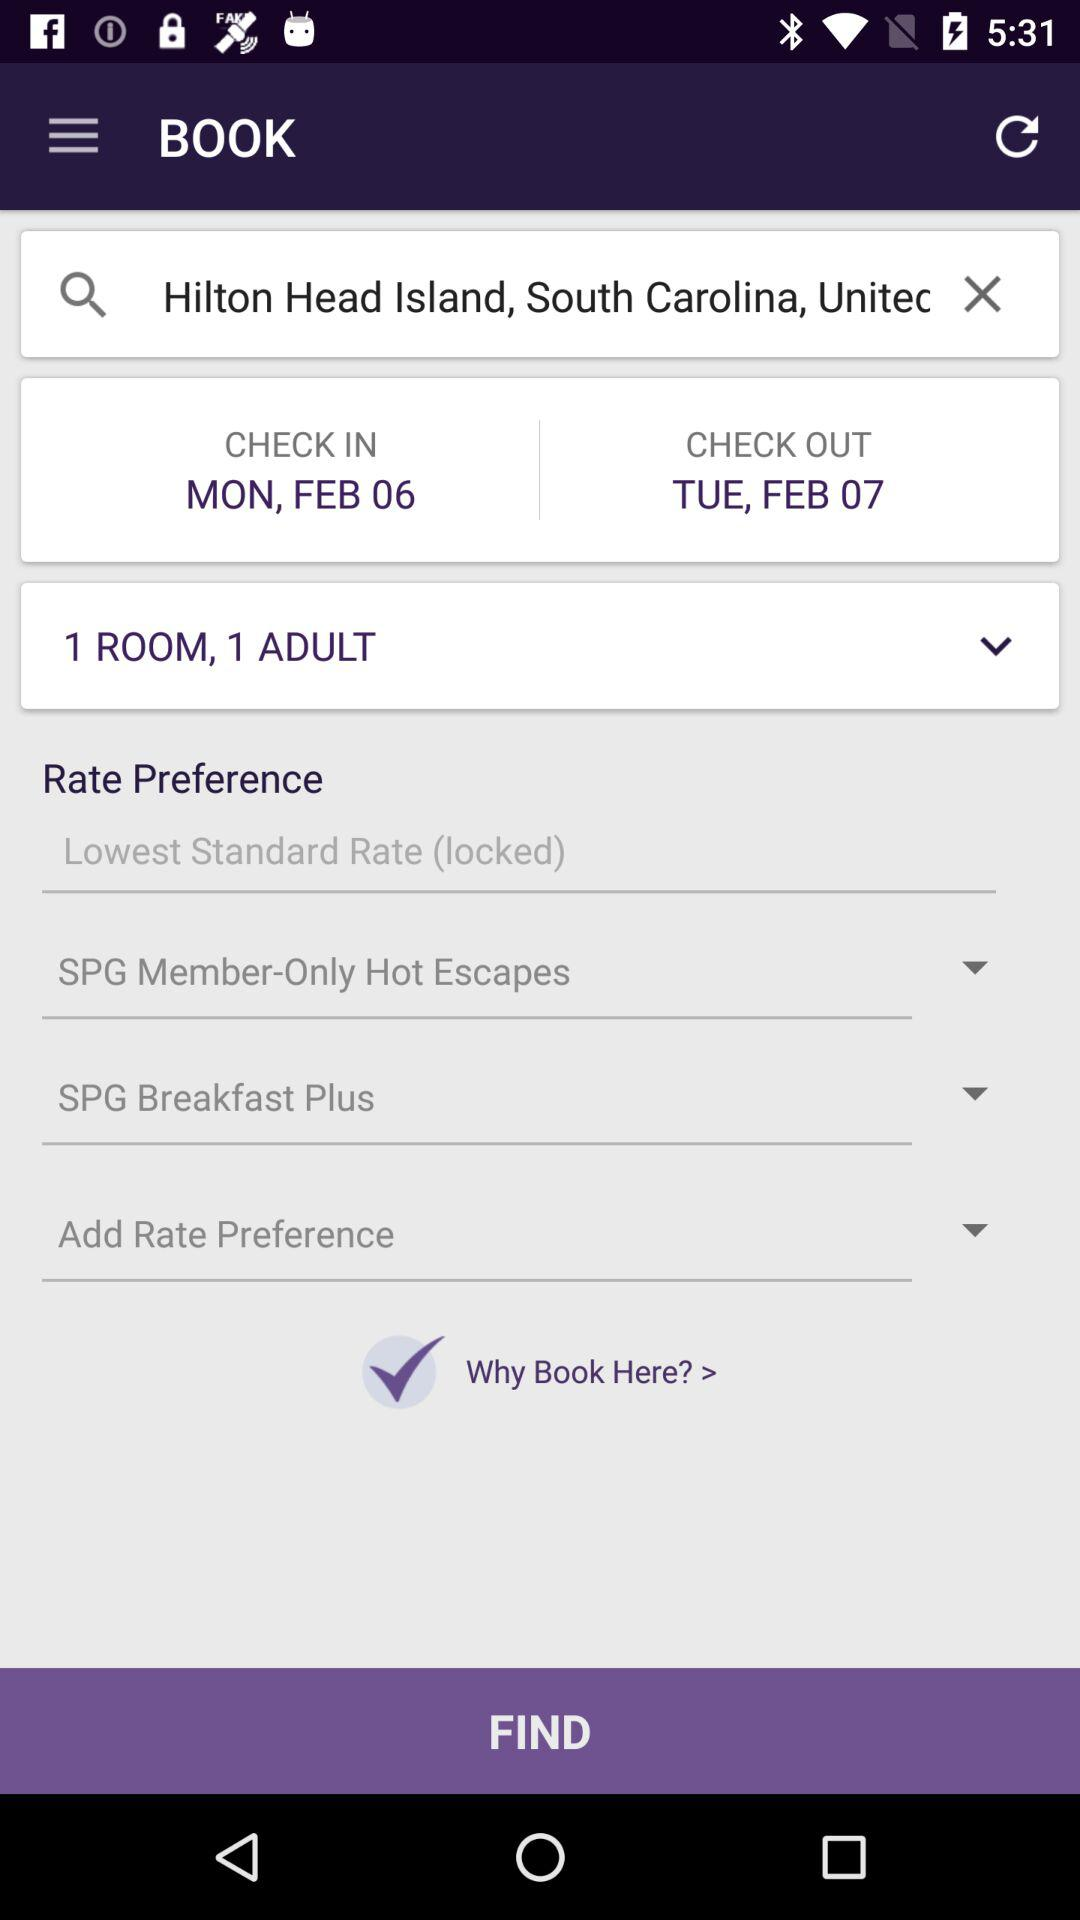How many rate preferences are available?
Answer the question using a single word or phrase. 3 